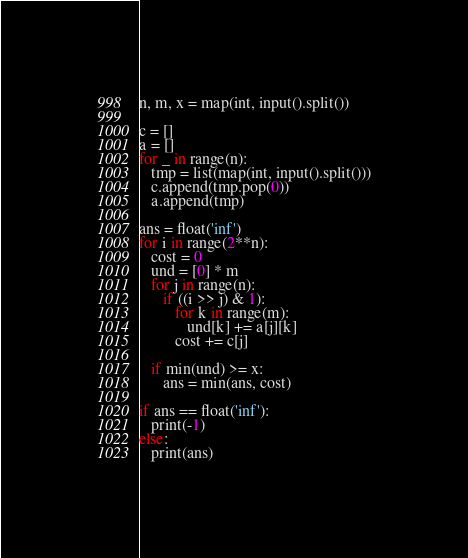Convert code to text. <code><loc_0><loc_0><loc_500><loc_500><_Python_>n, m, x = map(int, input().split())

c = []
a = []
for _ in range(n):
   tmp = list(map(int, input().split()))
   c.append(tmp.pop(0))
   a.append(tmp)

ans = float('inf')
for i in range(2**n):
   cost = 0
   und = [0] * m
   for j in range(n):
      if ((i >> j) & 1):
         for k in range(m):
            und[k] += a[j][k]
         cost += c[j]

   if min(und) >= x:
      ans = min(ans, cost)

if ans == float('inf'):
   print(-1)
else:
   print(ans)
</code> 